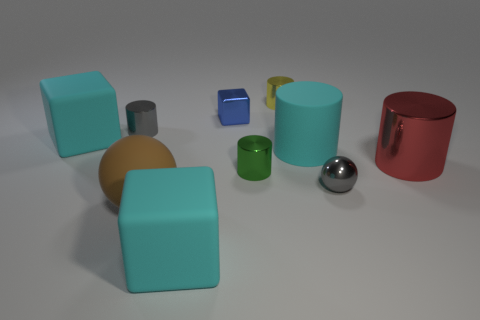There is a big matte cube that is in front of the brown matte ball; does it have the same color as the matte cylinder?
Your answer should be compact. Yes. What number of cylinders have the same color as the metallic ball?
Offer a terse response. 1. What size is the cylinder that is the same color as the metallic ball?
Provide a succinct answer. Small. Are there any other things that have the same color as the small metallic ball?
Keep it short and to the point. Yes. There is a block on the left side of the gray object that is behind the gray thing that is right of the yellow metal cylinder; how big is it?
Give a very brief answer. Large. There is a tiny blue thing; are there any gray things to the left of it?
Your answer should be compact. Yes. What is the size of the red cylinder that is the same material as the green object?
Provide a succinct answer. Large. What number of yellow things are the same shape as the green metallic object?
Ensure brevity in your answer.  1. Is the big red object made of the same material as the cyan thing right of the metal cube?
Provide a succinct answer. No. Is the number of cyan matte blocks left of the tiny gray cylinder greater than the number of big green rubber balls?
Give a very brief answer. Yes. 